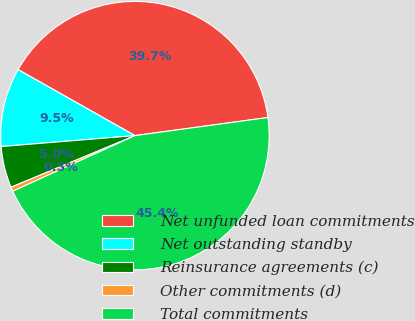Convert chart. <chart><loc_0><loc_0><loc_500><loc_500><pie_chart><fcel>Net unfunded loan commitments<fcel>Net outstanding standby<fcel>Reinsurance agreements (c)<fcel>Other commitments (d)<fcel>Total commitments<nl><fcel>39.66%<fcel>9.48%<fcel>4.99%<fcel>0.51%<fcel>45.36%<nl></chart> 